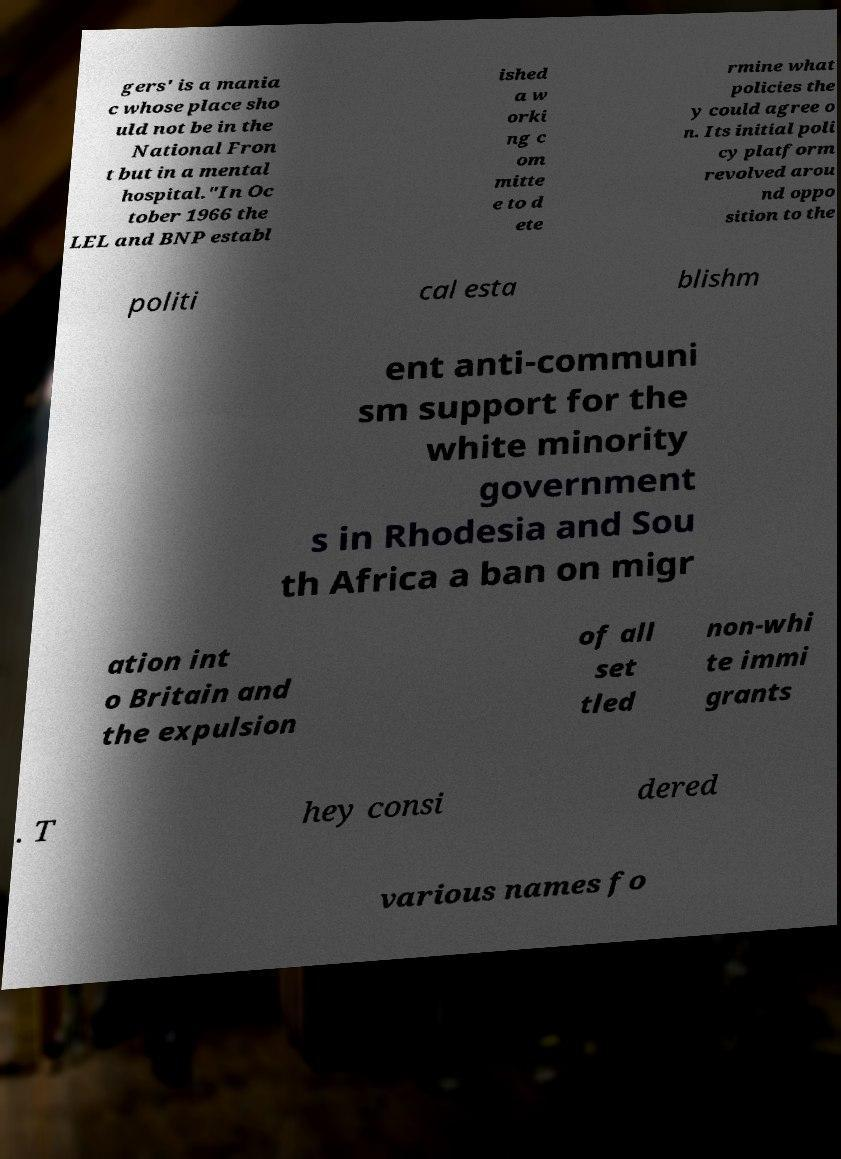Please read and relay the text visible in this image. What does it say? gers' is a mania c whose place sho uld not be in the National Fron t but in a mental hospital."In Oc tober 1966 the LEL and BNP establ ished a w orki ng c om mitte e to d ete rmine what policies the y could agree o n. Its initial poli cy platform revolved arou nd oppo sition to the politi cal esta blishm ent anti-communi sm support for the white minority government s in Rhodesia and Sou th Africa a ban on migr ation int o Britain and the expulsion of all set tled non-whi te immi grants . T hey consi dered various names fo 